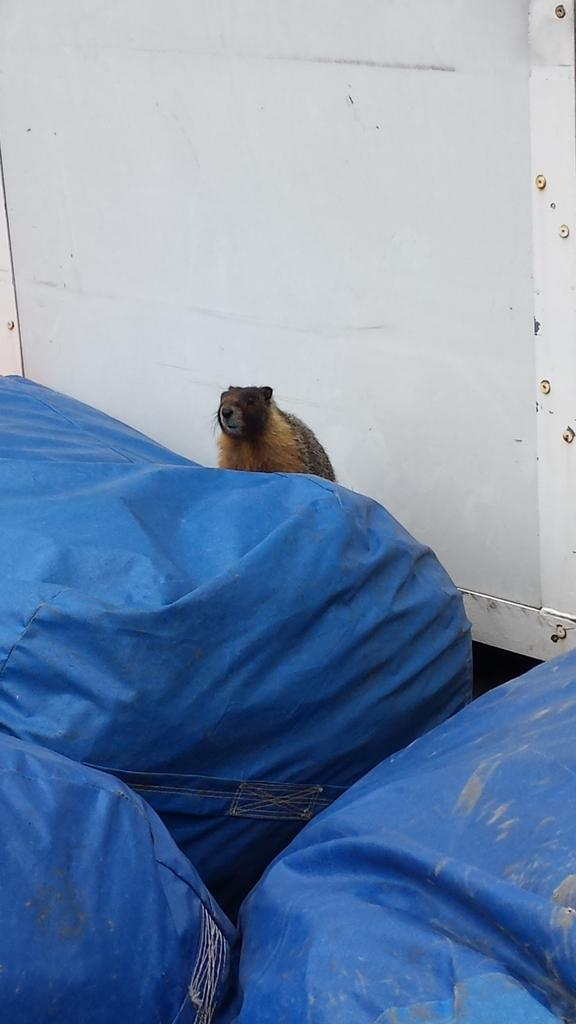What type of material is used for the covers in the image? The covers in the image are made of blue plastic. What animal is present in the image? There is a bear in the image. Where is the bear located in relation to the steel wall? The bear is near a steel wall in the image. How does the bear contribute to the health of the people in the image? The image does not provide any information about the health of the people or the bear's role in it. Does the bear sneeze in the image? There is no indication of the bear sneezing in the image. 